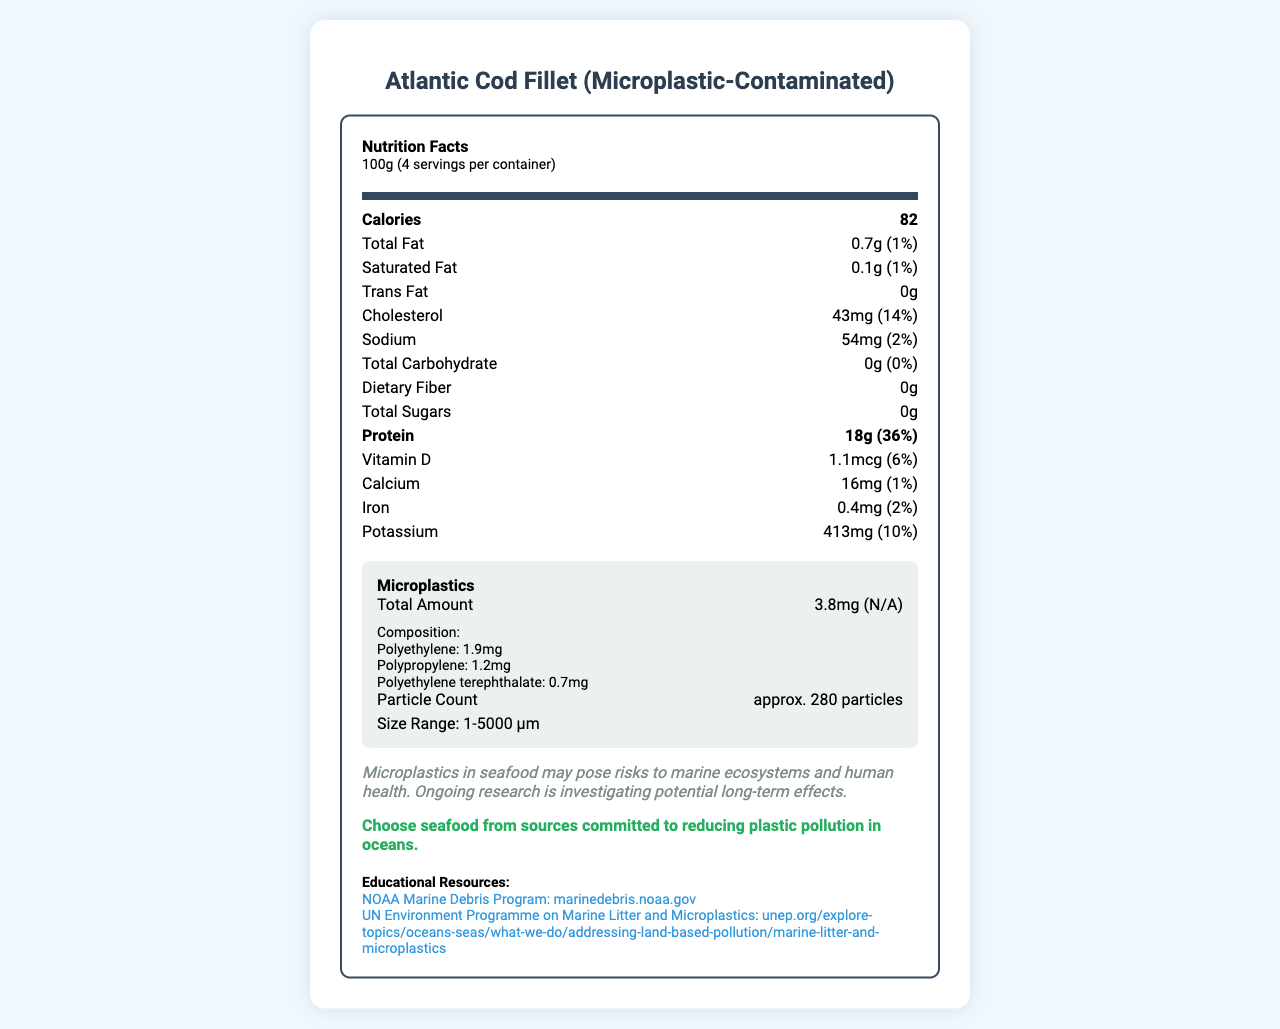what is the serving size? The serving size is listed as 100g under the serving information section.
Answer: 100g how many calories are in one serving? The calories per serving are directly mentioned as 82.
Answer: 82 what is the amount of total fat per serving? The total fat amount per serving is listed as 0.7g.
Answer: 0.7g how much microplastic is contained in a single serving? The total amount of microplastic per serving is listed as 3.8mg.
Answer: 3.8mg how much protein is in a 100g serving? The protein amount per 100g serving is shown as 18g.
Answer: 18g what is the primary type of microplastic found in this fish sample? Polyethylene is listed as the primary type of microplastic with 1.9mg.
Answer: Polyethylene how many different types of microplastics are listed in the document? The document lists three types of microplastics: polyethylene, polypropylene, and polyethylene terephthalate.
Answer: Three which nutrient has the highest percent Daily Value? A. Total Fat B. Cholesterol C. Protein D. Potassium The percent Daily Value for protein is 36%, which is the highest among the listed nutrients.
Answer: C. Protein which is true about the environmental impact statement? A. It highlights benefits B. It discusses potential risks C. It is not included D. It provides exact health effects The environmental impact statement mentions that microplastics may pose risks to marine ecosystems and human health.
Answer: B. It discusses potential risks is there any dietary fiber in the fish sample? The document lists dietary fiber as 0g.
Answer: No how is the size range of microplastic particles described? The size range is mentioned as 1-5000 μm in the microplastic particle count section.
Answer: 1-5000 μm what does the document say about sustainability? The sustainability note advises choosing seafood from sources that reduce plastic pollution in oceans.
Answer: Choose seafood from sources committed to reducing plastic pollution in oceans. summarize the main idea of the document. The document offers a comprehensive view of the nutrition and microplastic content of the fish, emphasizing both health and environmental considerations while providing resources for further education.
Answer: This document provides nutrition facts for a microplastic-contaminated Atlantic Cod Fillet. It includes traditional nutrition information such as calories, fat, protein, vitamins, and minerals, alongside details about microplastic content, composition, particle size, and environmental impacts. It also includes sustainability tips and educational resources for further information. how does the microplastic content affect the percent Daily Value? The document mentions "N/A" for the percent Daily Value of microplastics, so it cannot be determined how it affects the Daily Value.
Answer: Cannot be determined 